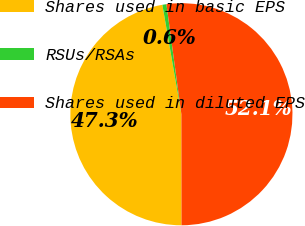Convert chart to OTSL. <chart><loc_0><loc_0><loc_500><loc_500><pie_chart><fcel>Shares used in basic EPS<fcel>RSUs/RSAs<fcel>Shares used in diluted EPS<nl><fcel>47.28%<fcel>0.59%<fcel>52.13%<nl></chart> 